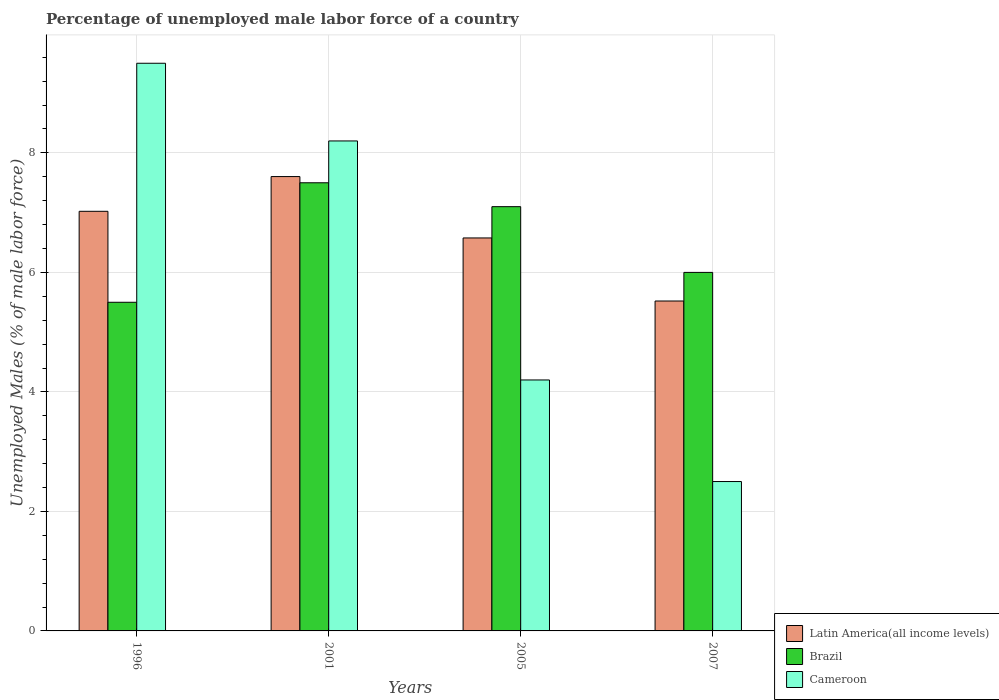How many different coloured bars are there?
Provide a succinct answer. 3. How many groups of bars are there?
Your answer should be compact. 4. Are the number of bars per tick equal to the number of legend labels?
Keep it short and to the point. Yes. Are the number of bars on each tick of the X-axis equal?
Your answer should be very brief. Yes. What is the label of the 2nd group of bars from the left?
Give a very brief answer. 2001. What is the percentage of unemployed male labor force in Latin America(all income levels) in 2007?
Keep it short and to the point. 5.52. Across all years, what is the minimum percentage of unemployed male labor force in Cameroon?
Offer a terse response. 2.5. In which year was the percentage of unemployed male labor force in Brazil maximum?
Keep it short and to the point. 2001. In which year was the percentage of unemployed male labor force in Latin America(all income levels) minimum?
Offer a very short reply. 2007. What is the total percentage of unemployed male labor force in Cameroon in the graph?
Make the answer very short. 24.4. What is the difference between the percentage of unemployed male labor force in Latin America(all income levels) in 1996 and that in 2007?
Provide a short and direct response. 1.5. What is the difference between the percentage of unemployed male labor force in Latin America(all income levels) in 2005 and the percentage of unemployed male labor force in Brazil in 2001?
Provide a short and direct response. -0.92. What is the average percentage of unemployed male labor force in Brazil per year?
Ensure brevity in your answer.  6.52. In the year 2005, what is the difference between the percentage of unemployed male labor force in Brazil and percentage of unemployed male labor force in Cameroon?
Provide a succinct answer. 2.9. In how many years, is the percentage of unemployed male labor force in Brazil greater than 2.4 %?
Provide a short and direct response. 4. What is the ratio of the percentage of unemployed male labor force in Latin America(all income levels) in 2001 to that in 2007?
Ensure brevity in your answer.  1.38. Is the difference between the percentage of unemployed male labor force in Brazil in 1996 and 2007 greater than the difference between the percentage of unemployed male labor force in Cameroon in 1996 and 2007?
Ensure brevity in your answer.  No. What is the difference between the highest and the second highest percentage of unemployed male labor force in Cameroon?
Give a very brief answer. 1.3. What is the difference between the highest and the lowest percentage of unemployed male labor force in Latin America(all income levels)?
Your response must be concise. 2.08. In how many years, is the percentage of unemployed male labor force in Cameroon greater than the average percentage of unemployed male labor force in Cameroon taken over all years?
Give a very brief answer. 2. What does the 2nd bar from the left in 1996 represents?
Offer a very short reply. Brazil. What does the 3rd bar from the right in 1996 represents?
Offer a very short reply. Latin America(all income levels). Is it the case that in every year, the sum of the percentage of unemployed male labor force in Cameroon and percentage of unemployed male labor force in Latin America(all income levels) is greater than the percentage of unemployed male labor force in Brazil?
Keep it short and to the point. Yes. Are all the bars in the graph horizontal?
Offer a very short reply. No. How many years are there in the graph?
Your answer should be very brief. 4. What is the difference between two consecutive major ticks on the Y-axis?
Provide a short and direct response. 2. Are the values on the major ticks of Y-axis written in scientific E-notation?
Provide a short and direct response. No. Does the graph contain any zero values?
Provide a succinct answer. No. Does the graph contain grids?
Keep it short and to the point. Yes. Where does the legend appear in the graph?
Give a very brief answer. Bottom right. What is the title of the graph?
Give a very brief answer. Percentage of unemployed male labor force of a country. Does "Burundi" appear as one of the legend labels in the graph?
Provide a succinct answer. No. What is the label or title of the Y-axis?
Your answer should be very brief. Unemployed Males (% of male labor force). What is the Unemployed Males (% of male labor force) in Latin America(all income levels) in 1996?
Make the answer very short. 7.02. What is the Unemployed Males (% of male labor force) in Latin America(all income levels) in 2001?
Ensure brevity in your answer.  7.6. What is the Unemployed Males (% of male labor force) of Cameroon in 2001?
Make the answer very short. 8.2. What is the Unemployed Males (% of male labor force) of Latin America(all income levels) in 2005?
Provide a short and direct response. 6.58. What is the Unemployed Males (% of male labor force) in Brazil in 2005?
Make the answer very short. 7.1. What is the Unemployed Males (% of male labor force) in Cameroon in 2005?
Offer a terse response. 4.2. What is the Unemployed Males (% of male labor force) in Latin America(all income levels) in 2007?
Give a very brief answer. 5.52. Across all years, what is the maximum Unemployed Males (% of male labor force) in Latin America(all income levels)?
Offer a very short reply. 7.6. Across all years, what is the minimum Unemployed Males (% of male labor force) in Latin America(all income levels)?
Your answer should be compact. 5.52. What is the total Unemployed Males (% of male labor force) of Latin America(all income levels) in the graph?
Give a very brief answer. 26.72. What is the total Unemployed Males (% of male labor force) of Brazil in the graph?
Your answer should be compact. 26.1. What is the total Unemployed Males (% of male labor force) of Cameroon in the graph?
Make the answer very short. 24.4. What is the difference between the Unemployed Males (% of male labor force) of Latin America(all income levels) in 1996 and that in 2001?
Ensure brevity in your answer.  -0.58. What is the difference between the Unemployed Males (% of male labor force) of Brazil in 1996 and that in 2001?
Give a very brief answer. -2. What is the difference between the Unemployed Males (% of male labor force) in Cameroon in 1996 and that in 2001?
Offer a terse response. 1.3. What is the difference between the Unemployed Males (% of male labor force) in Latin America(all income levels) in 1996 and that in 2005?
Provide a succinct answer. 0.45. What is the difference between the Unemployed Males (% of male labor force) in Latin America(all income levels) in 1996 and that in 2007?
Provide a succinct answer. 1.5. What is the difference between the Unemployed Males (% of male labor force) of Brazil in 1996 and that in 2007?
Make the answer very short. -0.5. What is the difference between the Unemployed Males (% of male labor force) in Cameroon in 1996 and that in 2007?
Your response must be concise. 7. What is the difference between the Unemployed Males (% of male labor force) of Latin America(all income levels) in 2001 and that in 2005?
Ensure brevity in your answer.  1.03. What is the difference between the Unemployed Males (% of male labor force) in Latin America(all income levels) in 2001 and that in 2007?
Provide a short and direct response. 2.08. What is the difference between the Unemployed Males (% of male labor force) of Brazil in 2001 and that in 2007?
Your answer should be compact. 1.5. What is the difference between the Unemployed Males (% of male labor force) in Latin America(all income levels) in 2005 and that in 2007?
Give a very brief answer. 1.06. What is the difference between the Unemployed Males (% of male labor force) in Cameroon in 2005 and that in 2007?
Your answer should be compact. 1.7. What is the difference between the Unemployed Males (% of male labor force) of Latin America(all income levels) in 1996 and the Unemployed Males (% of male labor force) of Brazil in 2001?
Offer a terse response. -0.48. What is the difference between the Unemployed Males (% of male labor force) in Latin America(all income levels) in 1996 and the Unemployed Males (% of male labor force) in Cameroon in 2001?
Keep it short and to the point. -1.18. What is the difference between the Unemployed Males (% of male labor force) in Brazil in 1996 and the Unemployed Males (% of male labor force) in Cameroon in 2001?
Make the answer very short. -2.7. What is the difference between the Unemployed Males (% of male labor force) in Latin America(all income levels) in 1996 and the Unemployed Males (% of male labor force) in Brazil in 2005?
Offer a very short reply. -0.08. What is the difference between the Unemployed Males (% of male labor force) of Latin America(all income levels) in 1996 and the Unemployed Males (% of male labor force) of Cameroon in 2005?
Keep it short and to the point. 2.82. What is the difference between the Unemployed Males (% of male labor force) in Brazil in 1996 and the Unemployed Males (% of male labor force) in Cameroon in 2005?
Give a very brief answer. 1.3. What is the difference between the Unemployed Males (% of male labor force) in Latin America(all income levels) in 1996 and the Unemployed Males (% of male labor force) in Brazil in 2007?
Offer a very short reply. 1.02. What is the difference between the Unemployed Males (% of male labor force) in Latin America(all income levels) in 1996 and the Unemployed Males (% of male labor force) in Cameroon in 2007?
Offer a very short reply. 4.52. What is the difference between the Unemployed Males (% of male labor force) in Brazil in 1996 and the Unemployed Males (% of male labor force) in Cameroon in 2007?
Your response must be concise. 3. What is the difference between the Unemployed Males (% of male labor force) of Latin America(all income levels) in 2001 and the Unemployed Males (% of male labor force) of Brazil in 2005?
Your answer should be very brief. 0.5. What is the difference between the Unemployed Males (% of male labor force) of Latin America(all income levels) in 2001 and the Unemployed Males (% of male labor force) of Cameroon in 2005?
Ensure brevity in your answer.  3.4. What is the difference between the Unemployed Males (% of male labor force) in Brazil in 2001 and the Unemployed Males (% of male labor force) in Cameroon in 2005?
Give a very brief answer. 3.3. What is the difference between the Unemployed Males (% of male labor force) of Latin America(all income levels) in 2001 and the Unemployed Males (% of male labor force) of Brazil in 2007?
Your answer should be compact. 1.6. What is the difference between the Unemployed Males (% of male labor force) in Latin America(all income levels) in 2001 and the Unemployed Males (% of male labor force) in Cameroon in 2007?
Make the answer very short. 5.1. What is the difference between the Unemployed Males (% of male labor force) in Brazil in 2001 and the Unemployed Males (% of male labor force) in Cameroon in 2007?
Your answer should be compact. 5. What is the difference between the Unemployed Males (% of male labor force) in Latin America(all income levels) in 2005 and the Unemployed Males (% of male labor force) in Brazil in 2007?
Make the answer very short. 0.58. What is the difference between the Unemployed Males (% of male labor force) of Latin America(all income levels) in 2005 and the Unemployed Males (% of male labor force) of Cameroon in 2007?
Your answer should be compact. 4.08. What is the average Unemployed Males (% of male labor force) of Latin America(all income levels) per year?
Provide a short and direct response. 6.68. What is the average Unemployed Males (% of male labor force) of Brazil per year?
Your answer should be very brief. 6.53. In the year 1996, what is the difference between the Unemployed Males (% of male labor force) of Latin America(all income levels) and Unemployed Males (% of male labor force) of Brazil?
Your answer should be compact. 1.52. In the year 1996, what is the difference between the Unemployed Males (% of male labor force) in Latin America(all income levels) and Unemployed Males (% of male labor force) in Cameroon?
Offer a very short reply. -2.48. In the year 2001, what is the difference between the Unemployed Males (% of male labor force) in Latin America(all income levels) and Unemployed Males (% of male labor force) in Brazil?
Provide a short and direct response. 0.1. In the year 2001, what is the difference between the Unemployed Males (% of male labor force) of Latin America(all income levels) and Unemployed Males (% of male labor force) of Cameroon?
Provide a succinct answer. -0.6. In the year 2001, what is the difference between the Unemployed Males (% of male labor force) of Brazil and Unemployed Males (% of male labor force) of Cameroon?
Offer a very short reply. -0.7. In the year 2005, what is the difference between the Unemployed Males (% of male labor force) of Latin America(all income levels) and Unemployed Males (% of male labor force) of Brazil?
Make the answer very short. -0.52. In the year 2005, what is the difference between the Unemployed Males (% of male labor force) in Latin America(all income levels) and Unemployed Males (% of male labor force) in Cameroon?
Offer a very short reply. 2.38. In the year 2007, what is the difference between the Unemployed Males (% of male labor force) of Latin America(all income levels) and Unemployed Males (% of male labor force) of Brazil?
Your answer should be compact. -0.48. In the year 2007, what is the difference between the Unemployed Males (% of male labor force) in Latin America(all income levels) and Unemployed Males (% of male labor force) in Cameroon?
Offer a very short reply. 3.02. What is the ratio of the Unemployed Males (% of male labor force) in Latin America(all income levels) in 1996 to that in 2001?
Ensure brevity in your answer.  0.92. What is the ratio of the Unemployed Males (% of male labor force) in Brazil in 1996 to that in 2001?
Give a very brief answer. 0.73. What is the ratio of the Unemployed Males (% of male labor force) of Cameroon in 1996 to that in 2001?
Provide a succinct answer. 1.16. What is the ratio of the Unemployed Males (% of male labor force) in Latin America(all income levels) in 1996 to that in 2005?
Ensure brevity in your answer.  1.07. What is the ratio of the Unemployed Males (% of male labor force) in Brazil in 1996 to that in 2005?
Give a very brief answer. 0.77. What is the ratio of the Unemployed Males (% of male labor force) of Cameroon in 1996 to that in 2005?
Your answer should be very brief. 2.26. What is the ratio of the Unemployed Males (% of male labor force) in Latin America(all income levels) in 1996 to that in 2007?
Offer a very short reply. 1.27. What is the ratio of the Unemployed Males (% of male labor force) in Brazil in 1996 to that in 2007?
Give a very brief answer. 0.92. What is the ratio of the Unemployed Males (% of male labor force) in Cameroon in 1996 to that in 2007?
Offer a very short reply. 3.8. What is the ratio of the Unemployed Males (% of male labor force) in Latin America(all income levels) in 2001 to that in 2005?
Provide a succinct answer. 1.16. What is the ratio of the Unemployed Males (% of male labor force) of Brazil in 2001 to that in 2005?
Provide a short and direct response. 1.06. What is the ratio of the Unemployed Males (% of male labor force) of Cameroon in 2001 to that in 2005?
Your answer should be compact. 1.95. What is the ratio of the Unemployed Males (% of male labor force) of Latin America(all income levels) in 2001 to that in 2007?
Your answer should be compact. 1.38. What is the ratio of the Unemployed Males (% of male labor force) in Brazil in 2001 to that in 2007?
Provide a short and direct response. 1.25. What is the ratio of the Unemployed Males (% of male labor force) in Cameroon in 2001 to that in 2007?
Provide a succinct answer. 3.28. What is the ratio of the Unemployed Males (% of male labor force) in Latin America(all income levels) in 2005 to that in 2007?
Make the answer very short. 1.19. What is the ratio of the Unemployed Males (% of male labor force) in Brazil in 2005 to that in 2007?
Provide a short and direct response. 1.18. What is the ratio of the Unemployed Males (% of male labor force) in Cameroon in 2005 to that in 2007?
Your answer should be very brief. 1.68. What is the difference between the highest and the second highest Unemployed Males (% of male labor force) of Latin America(all income levels)?
Your answer should be compact. 0.58. What is the difference between the highest and the second highest Unemployed Males (% of male labor force) in Brazil?
Provide a succinct answer. 0.4. What is the difference between the highest and the lowest Unemployed Males (% of male labor force) of Latin America(all income levels)?
Offer a very short reply. 2.08. What is the difference between the highest and the lowest Unemployed Males (% of male labor force) in Cameroon?
Your answer should be very brief. 7. 